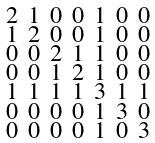Convert formula to latex. <formula><loc_0><loc_0><loc_500><loc_500>\begin{smallmatrix} 2 & 1 & 0 & 0 & 1 & 0 & 0 \\ 1 & 2 & 0 & 0 & 1 & 0 & 0 \\ 0 & 0 & 2 & 1 & 1 & 0 & 0 \\ 0 & 0 & 1 & 2 & 1 & 0 & 0 \\ 1 & 1 & 1 & 1 & 3 & 1 & 1 \\ 0 & 0 & 0 & 0 & 1 & 3 & 0 \\ 0 & 0 & 0 & 0 & 1 & 0 & 3 \end{smallmatrix}</formula> 